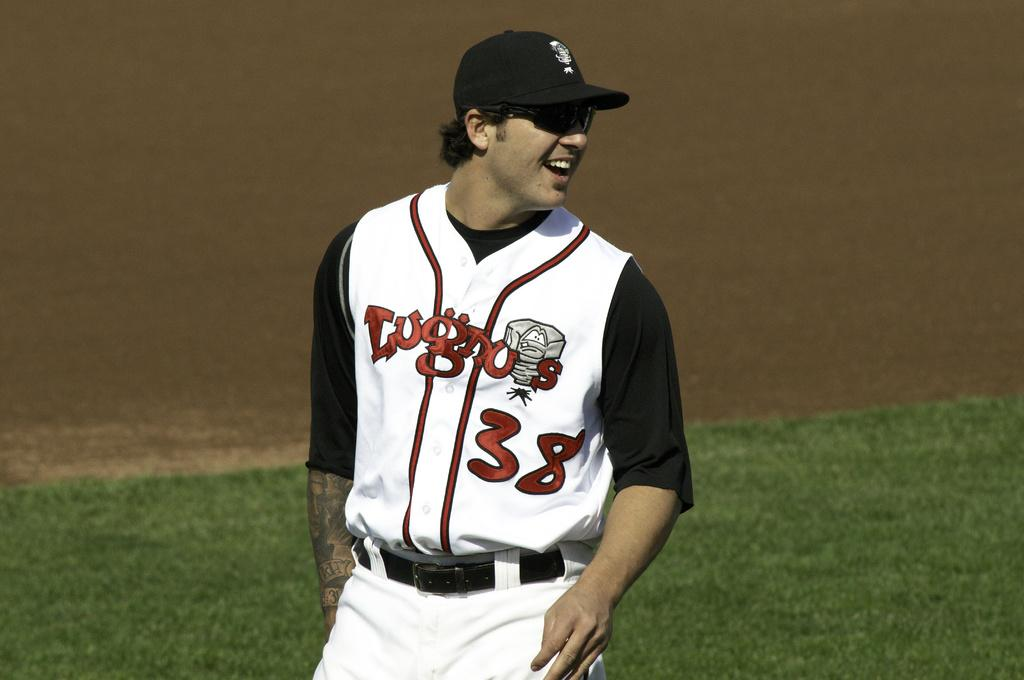<image>
Relay a brief, clear account of the picture shown. A baseball player wearing a black cap and he number 38 laughs as he stahds on the field. 